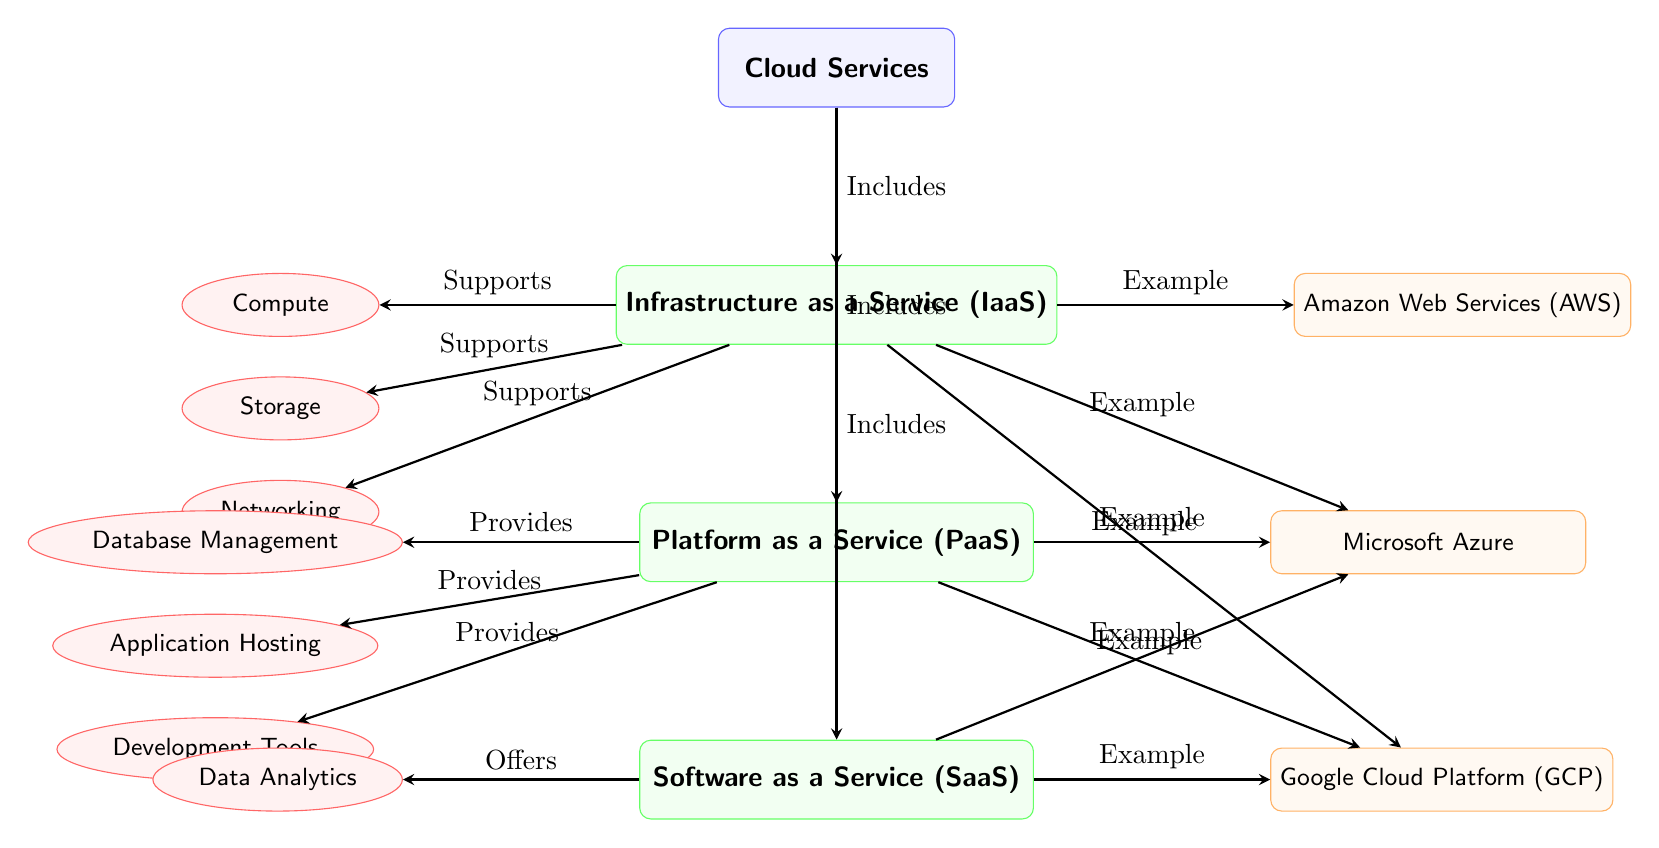What are the three main types of cloud services depicted in the diagram? The diagram shows three main types of cloud services: Infrastructure as a Service (IaaS), Platform as a Service (PaaS), and Software as a Service (SaaS).
Answer: IaaS, PaaS, SaaS Which cloud service model includes Compute, Storage, and Networking? The diagram indicates that the Infrastructure as a Service (IaaS) model includes Compute, Storage, and Networking as its services.
Answer: IaaS How many examples are provided for the Platform as a Service (PaaS) model? Upon examining the diagram, there are two examples provided for the PaaS model, which are Microsoft Azure and Google Cloud Platform (GCP).
Answer: 2 What service does the Software as a Service (SaaS) model offer? The diagram states that the Software as a Service (SaaS) model offers Data Analytics as its service.
Answer: Data Analytics Which two cloud service models mention Microsoft Azure as an example? The diagram shows that Microsoft Azure is mentioned as an example in both the Platform as a Service (PaaS) and Software as a Service (SaaS) models.
Answer: PaaS, SaaS What type of relationship does the cloud services category have with the IaaS, PaaS, and SaaS models? The diagram illustrates that the cloud services category includes the IaaS, PaaS, and SaaS models, as indicated by the arrows pointing from the cloud services category to each model.
Answer: Includes How many services are associated with the IaaS model? Analyzing the diagram reveals that there are three services associated with the IaaS model: Compute, Storage, and Networking.
Answer: 3 What is the primary function of the PaaS model based on the services listed? The services listed for the PaaS model, such as Database Management, Application Hosting, and Development Tools, illustrate that its primary function is to provide a platform for developers to create and manage applications.
Answer: Provides Which service model has only one service listed in the diagram, and what is that service? The diagram indicates that the Software as a Service (SaaS) model has only one service listed, which is Data Analytics.
Answer: SaaS, Data Analytics 